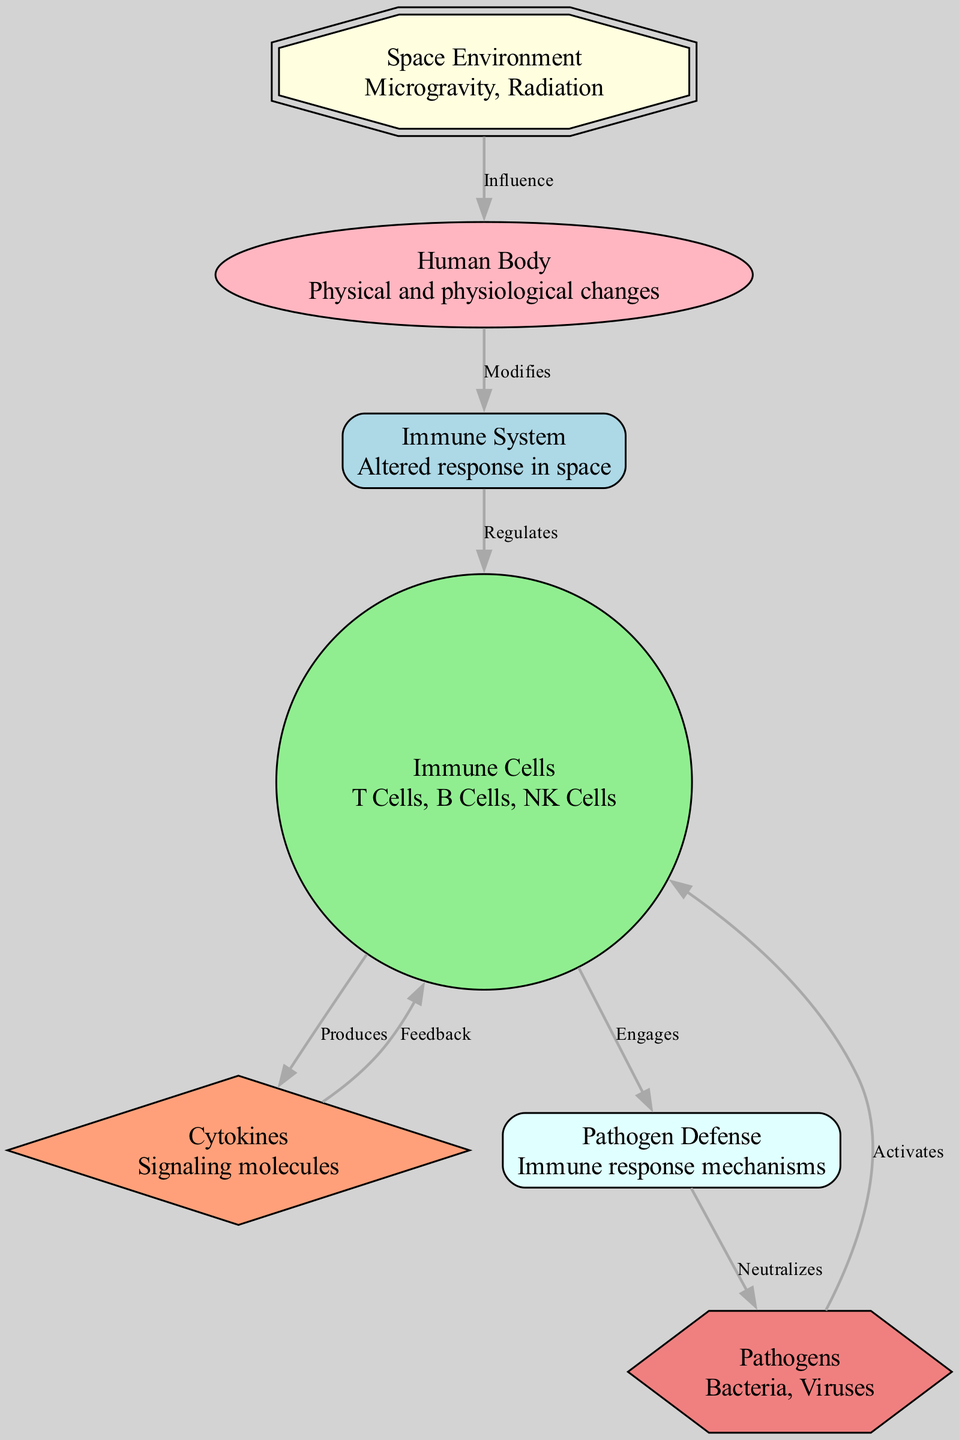What is the first node in the diagram? The first node listed in the data is "space_environment," which represents the aspects of microgravity and radiation experienced in space.
Answer: space_environment How many immune cell types are included in the diagram? The diagram mentions three types of immune cells: T Cells, B Cells, and NK Cells, which are specifically stated under the "immune_cells" node.
Answer: 3 What relationship does the "human_body" node have with the "immune_system" node? The "human_body" node is linked to the "immune_system" node with the label "Modifies," indicating that changes in the human body influence the immune system.
Answer: Modifies Which node produces cytokines? The "immune_cells" node is connected to the "cytokines" node with the label "Produces," indicating that immune cells are responsible for the production of cytokines.
Answer: Immune Cells How does the "pathogen_defense" node relate to the "pathogens" node? The "pathogen_defense" node is linked to the "pathogens" node with the label "Neutralizes," indicating that pathogen defense mechanisms serve to neutralize pathogens.
Answer: Neutralizes What is the feedback relationship in the diagram? The diagram shows a feedback relationship where the "cytokines" node sends feedback to the "immune_cells" node, indicating that cytokines influence immune cell activity.
Answer: Cytokines Which node activates immune cells? The "pathogens" node activates immune cells, according to the connection labeled "Activates," indicating that the presence of pathogens leads to immune cell activation.
Answer: Pathogens What is the overall trend shown in the diagram regarding space influence? The overall trend depicts that the "space_environment" leads to alterations in the "human_body," which modifies the "immune_system" and subsequently affects various immune functions.
Answer: Alters immune response What type of molecules are cytokines categorized as in the diagram? Cytokines are categorized as "Signaling molecules," which is mentioned in their description in the diagram.
Answer: Signaling molecules 